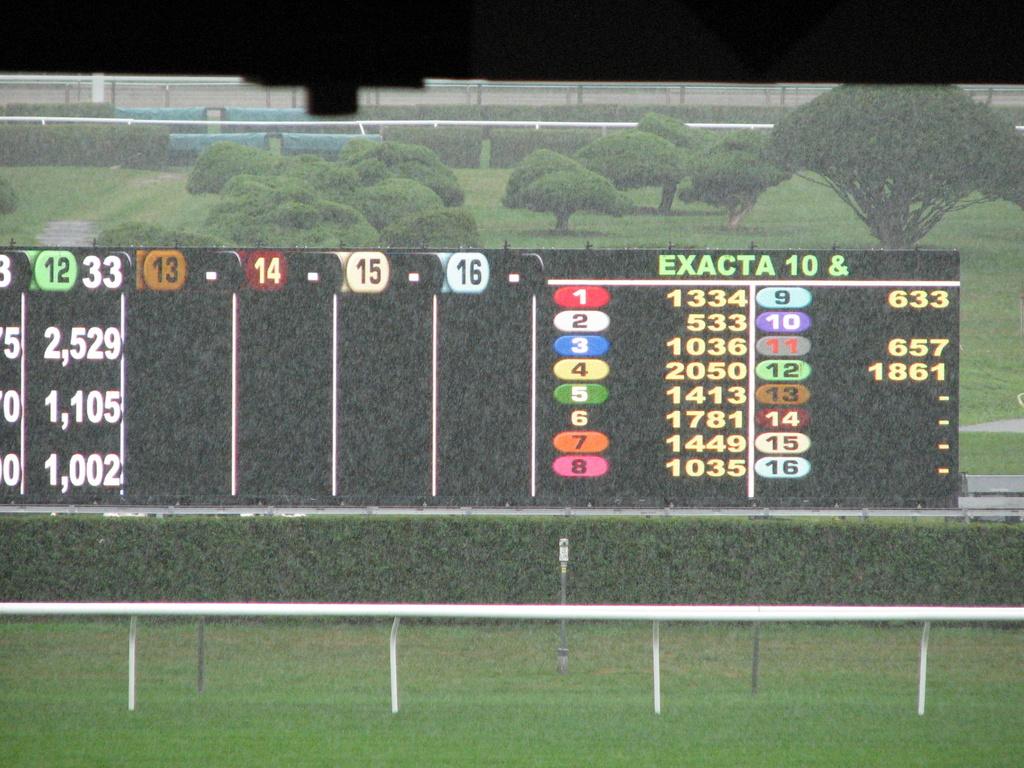What does it say on the top right?
Your response must be concise. Exacta 10 &. What number is written in white on red?
Your answer should be compact. 1. 